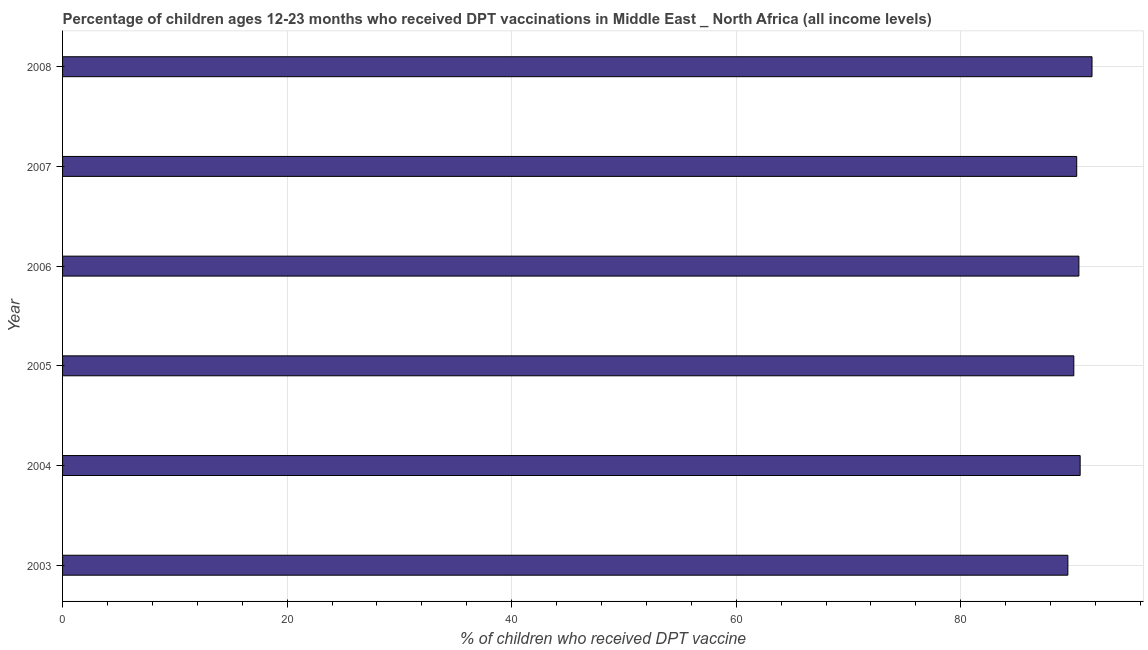Does the graph contain any zero values?
Give a very brief answer. No. Does the graph contain grids?
Your answer should be compact. Yes. What is the title of the graph?
Provide a succinct answer. Percentage of children ages 12-23 months who received DPT vaccinations in Middle East _ North Africa (all income levels). What is the label or title of the X-axis?
Provide a succinct answer. % of children who received DPT vaccine. What is the label or title of the Y-axis?
Keep it short and to the point. Year. What is the percentage of children who received dpt vaccine in 2004?
Keep it short and to the point. 90.63. Across all years, what is the maximum percentage of children who received dpt vaccine?
Ensure brevity in your answer.  91.69. Across all years, what is the minimum percentage of children who received dpt vaccine?
Your answer should be very brief. 89.54. What is the sum of the percentage of children who received dpt vaccine?
Offer a very short reply. 542.79. What is the difference between the percentage of children who received dpt vaccine in 2003 and 2005?
Provide a short and direct response. -0.53. What is the average percentage of children who received dpt vaccine per year?
Give a very brief answer. 90.46. What is the median percentage of children who received dpt vaccine?
Keep it short and to the point. 90.43. Do a majority of the years between 2003 and 2005 (inclusive) have percentage of children who received dpt vaccine greater than 16 %?
Your response must be concise. Yes. What is the ratio of the percentage of children who received dpt vaccine in 2006 to that in 2007?
Give a very brief answer. 1. Is the percentage of children who received dpt vaccine in 2005 less than that in 2006?
Keep it short and to the point. Yes. Is the difference between the percentage of children who received dpt vaccine in 2003 and 2008 greater than the difference between any two years?
Provide a succinct answer. Yes. What is the difference between the highest and the second highest percentage of children who received dpt vaccine?
Keep it short and to the point. 1.06. Is the sum of the percentage of children who received dpt vaccine in 2003 and 2006 greater than the maximum percentage of children who received dpt vaccine across all years?
Keep it short and to the point. Yes. What is the difference between the highest and the lowest percentage of children who received dpt vaccine?
Give a very brief answer. 2.15. Are the values on the major ticks of X-axis written in scientific E-notation?
Provide a short and direct response. No. What is the % of children who received DPT vaccine of 2003?
Provide a succinct answer. 89.54. What is the % of children who received DPT vaccine of 2004?
Ensure brevity in your answer.  90.63. What is the % of children who received DPT vaccine in 2005?
Make the answer very short. 90.07. What is the % of children who received DPT vaccine in 2006?
Give a very brief answer. 90.52. What is the % of children who received DPT vaccine in 2007?
Provide a succinct answer. 90.33. What is the % of children who received DPT vaccine in 2008?
Your answer should be compact. 91.69. What is the difference between the % of children who received DPT vaccine in 2003 and 2004?
Ensure brevity in your answer.  -1.09. What is the difference between the % of children who received DPT vaccine in 2003 and 2005?
Ensure brevity in your answer.  -0.53. What is the difference between the % of children who received DPT vaccine in 2003 and 2006?
Make the answer very short. -0.98. What is the difference between the % of children who received DPT vaccine in 2003 and 2007?
Offer a very short reply. -0.79. What is the difference between the % of children who received DPT vaccine in 2003 and 2008?
Provide a short and direct response. -2.15. What is the difference between the % of children who received DPT vaccine in 2004 and 2005?
Offer a very short reply. 0.57. What is the difference between the % of children who received DPT vaccine in 2004 and 2006?
Give a very brief answer. 0.11. What is the difference between the % of children who received DPT vaccine in 2004 and 2007?
Make the answer very short. 0.31. What is the difference between the % of children who received DPT vaccine in 2004 and 2008?
Your response must be concise. -1.06. What is the difference between the % of children who received DPT vaccine in 2005 and 2006?
Give a very brief answer. -0.45. What is the difference between the % of children who received DPT vaccine in 2005 and 2007?
Ensure brevity in your answer.  -0.26. What is the difference between the % of children who received DPT vaccine in 2005 and 2008?
Make the answer very short. -1.62. What is the difference between the % of children who received DPT vaccine in 2006 and 2007?
Offer a very short reply. 0.19. What is the difference between the % of children who received DPT vaccine in 2006 and 2008?
Provide a short and direct response. -1.17. What is the difference between the % of children who received DPT vaccine in 2007 and 2008?
Ensure brevity in your answer.  -1.36. What is the ratio of the % of children who received DPT vaccine in 2003 to that in 2004?
Provide a succinct answer. 0.99. What is the ratio of the % of children who received DPT vaccine in 2003 to that in 2006?
Your answer should be compact. 0.99. What is the ratio of the % of children who received DPT vaccine in 2003 to that in 2007?
Provide a succinct answer. 0.99. What is the ratio of the % of children who received DPT vaccine in 2003 to that in 2008?
Provide a succinct answer. 0.98. What is the ratio of the % of children who received DPT vaccine in 2004 to that in 2005?
Offer a very short reply. 1.01. What is the ratio of the % of children who received DPT vaccine in 2005 to that in 2006?
Your answer should be compact. 0.99. What is the ratio of the % of children who received DPT vaccine in 2005 to that in 2008?
Keep it short and to the point. 0.98. 